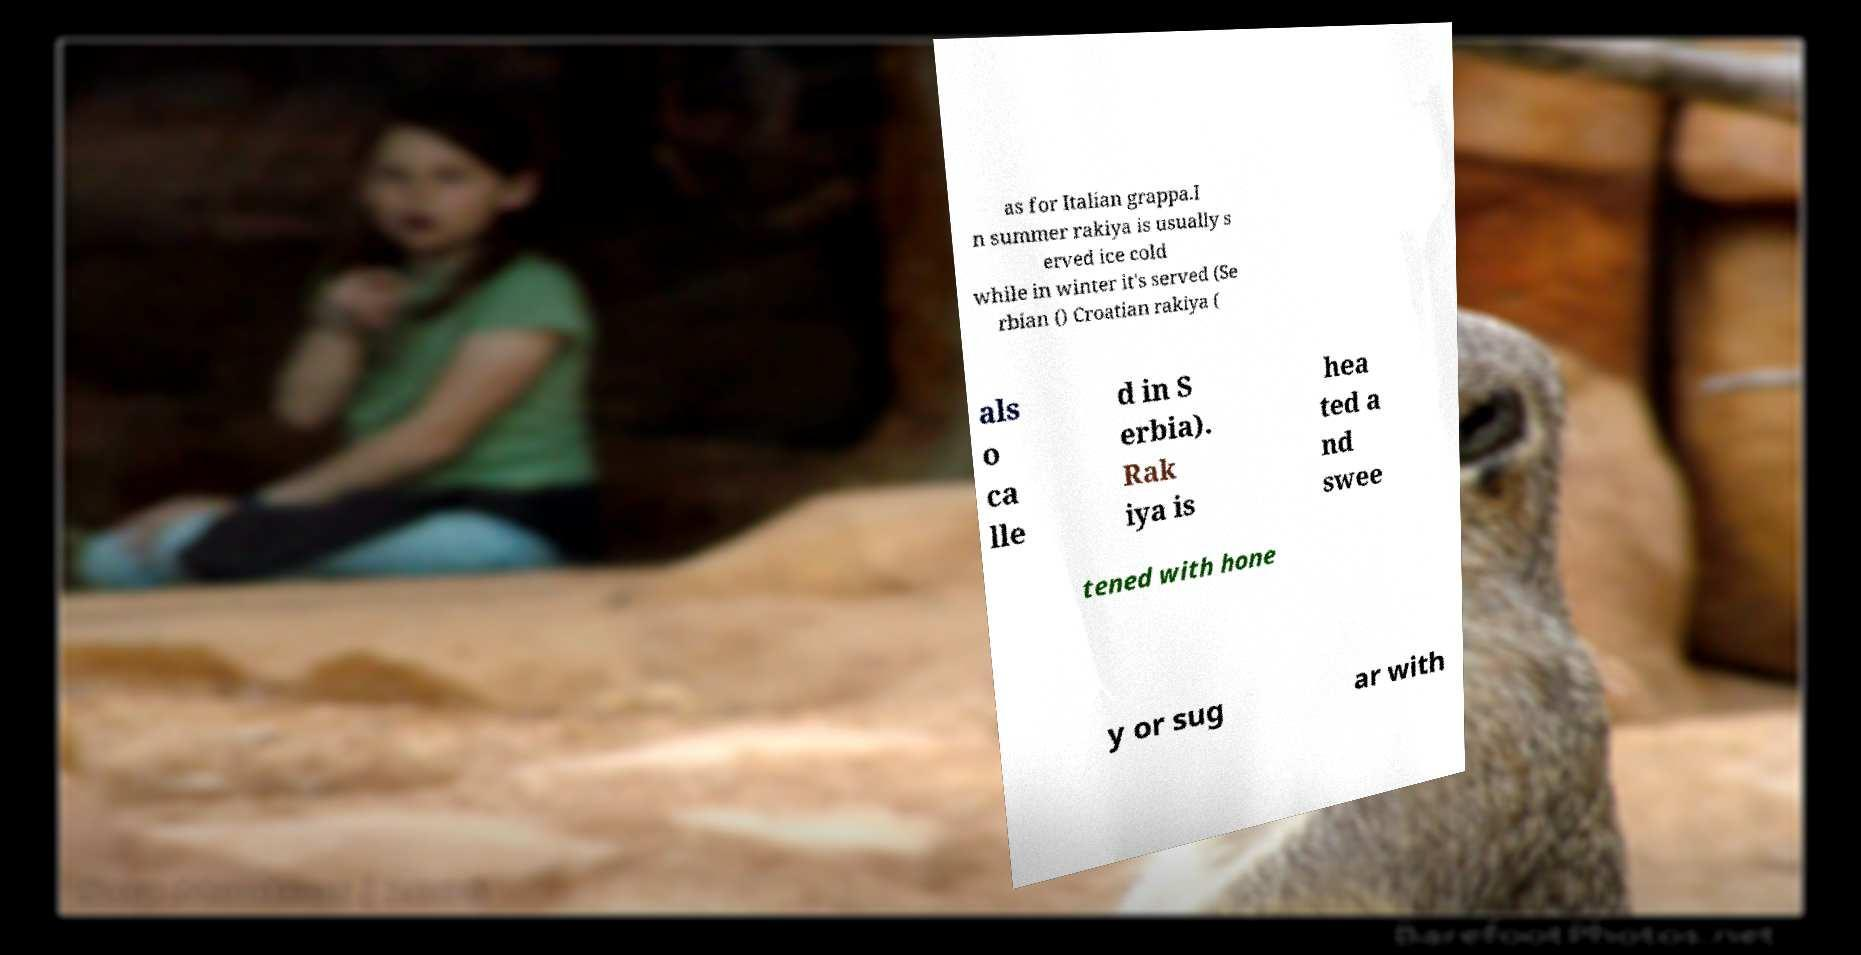Please read and relay the text visible in this image. What does it say? as for Italian grappa.I n summer rakiya is usually s erved ice cold while in winter it's served (Se rbian () Croatian rakiya ( als o ca lle d in S erbia). Rak iya is hea ted a nd swee tened with hone y or sug ar with 